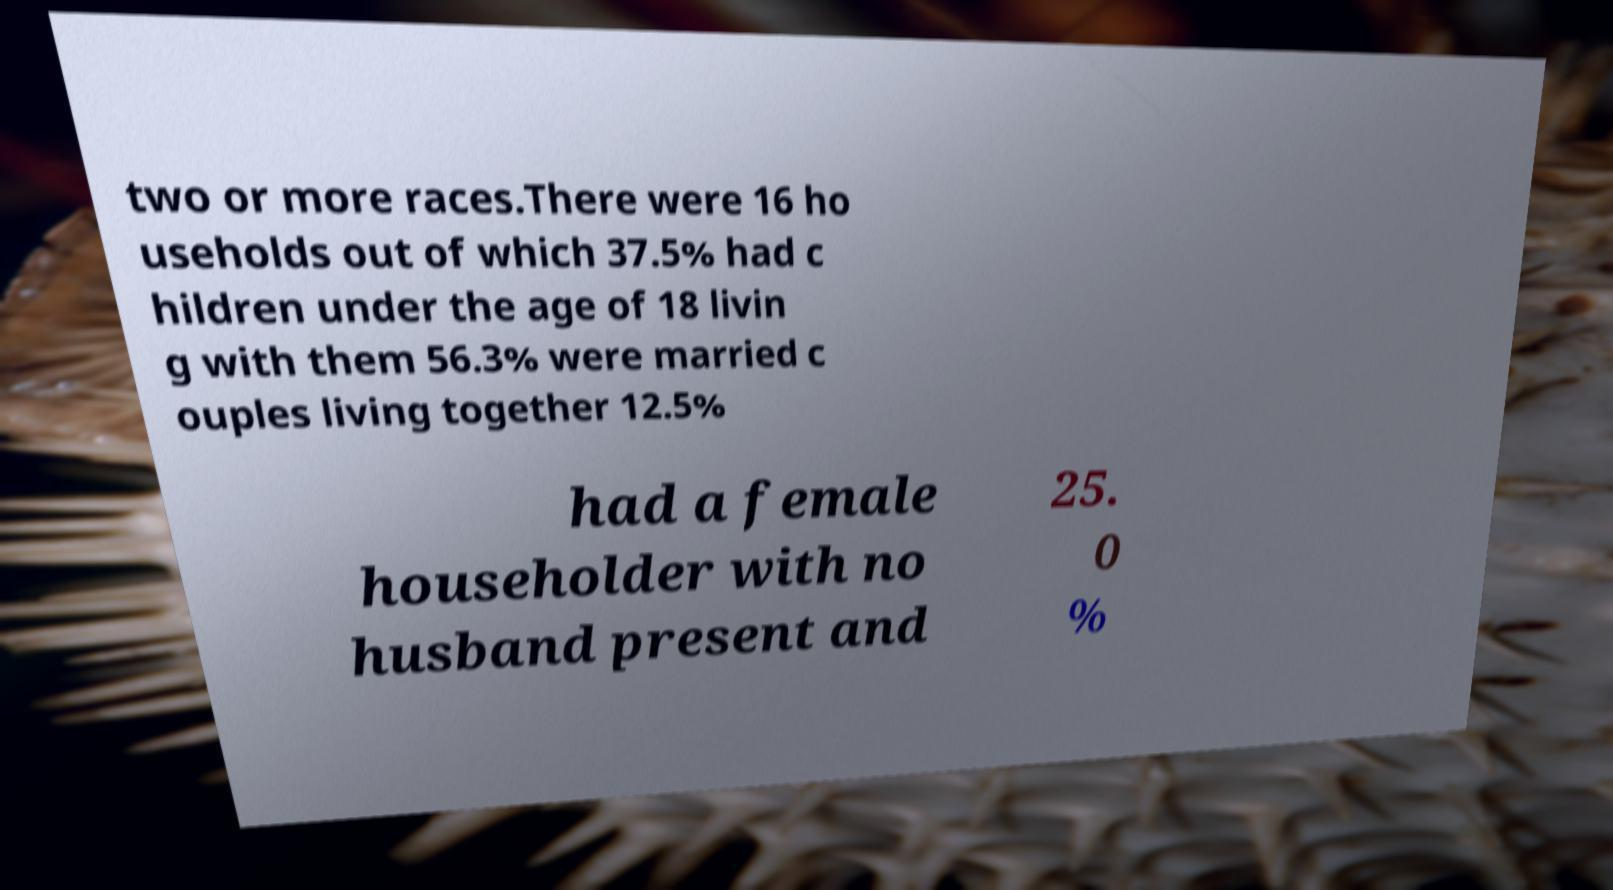For documentation purposes, I need the text within this image transcribed. Could you provide that? two or more races.There were 16 ho useholds out of which 37.5% had c hildren under the age of 18 livin g with them 56.3% were married c ouples living together 12.5% had a female householder with no husband present and 25. 0 % 